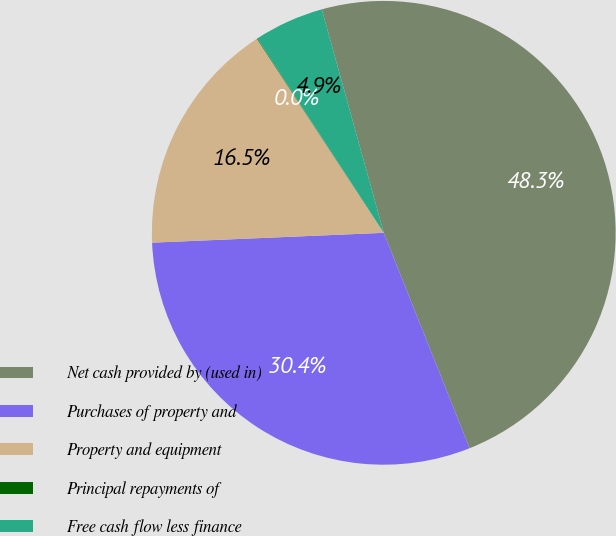<chart> <loc_0><loc_0><loc_500><loc_500><pie_chart><fcel>Net cash provided by (used in)<fcel>Purchases of property and<fcel>Property and equipment<fcel>Principal repayments of<fcel>Free cash flow less finance<nl><fcel>48.27%<fcel>30.36%<fcel>16.46%<fcel>0.04%<fcel>4.87%<nl></chart> 